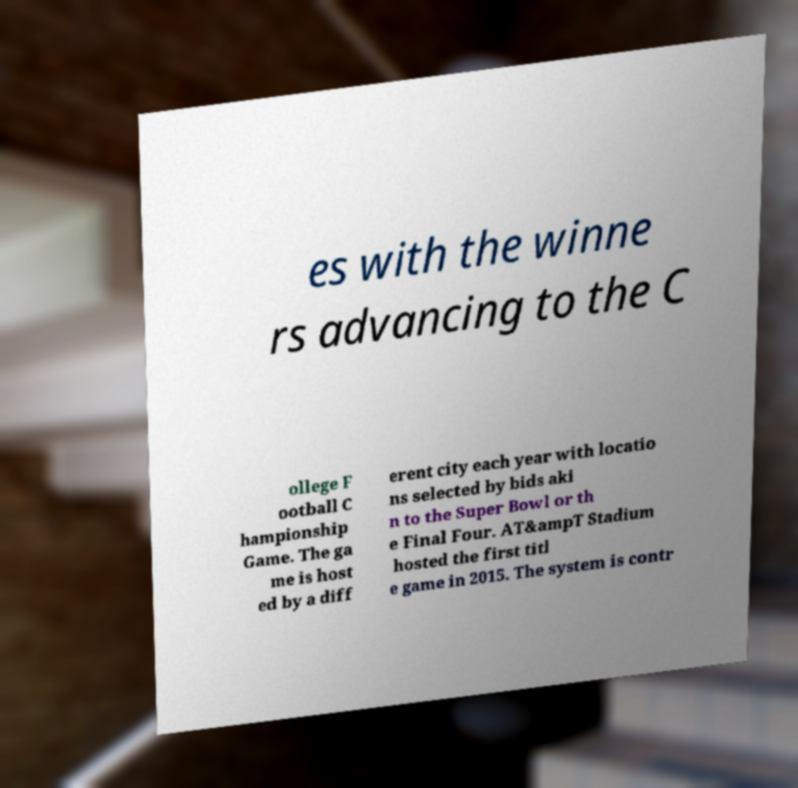What messages or text are displayed in this image? I need them in a readable, typed format. es with the winne rs advancing to the C ollege F ootball C hampionship Game. The ga me is host ed by a diff erent city each year with locatio ns selected by bids aki n to the Super Bowl or th e Final Four. AT&ampT Stadium hosted the first titl e game in 2015. The system is contr 